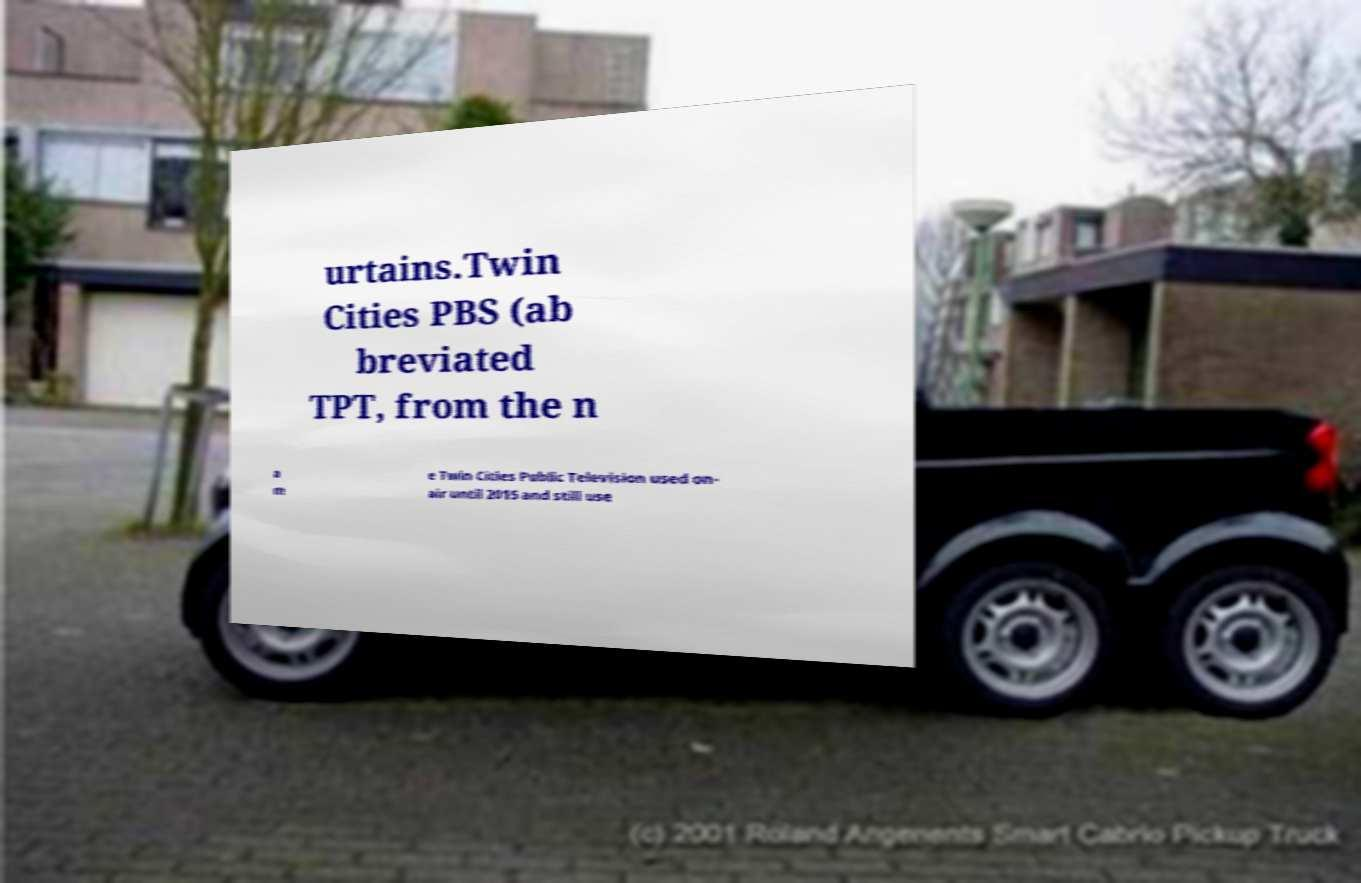For documentation purposes, I need the text within this image transcribed. Could you provide that? urtains.Twin Cities PBS (ab breviated TPT, from the n a m e Twin Cities Public Television used on- air until 2015 and still use 